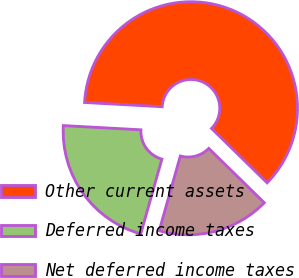<chart> <loc_0><loc_0><loc_500><loc_500><pie_chart><fcel>Other current assets<fcel>Deferred income taxes<fcel>Net deferred income taxes<nl><fcel>61.46%<fcel>21.49%<fcel>17.05%<nl></chart> 